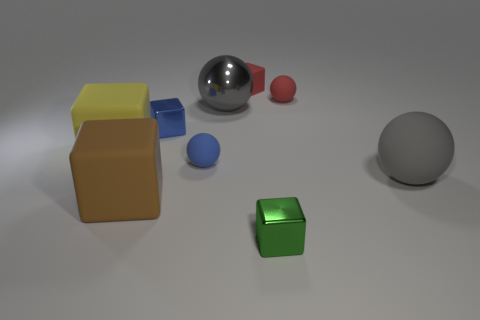Subtract all purple cubes. How many gray spheres are left? 2 Subtract all big yellow matte blocks. How many blocks are left? 4 Subtract 2 balls. How many balls are left? 2 Add 1 tiny green cylinders. How many objects exist? 10 Subtract all red spheres. How many spheres are left? 3 Subtract all brown cubes. Subtract all green cylinders. How many cubes are left? 4 Subtract all spheres. How many objects are left? 5 Subtract all large yellow blocks. Subtract all tiny yellow shiny blocks. How many objects are left? 8 Add 8 red things. How many red things are left? 10 Add 1 red cylinders. How many red cylinders exist? 1 